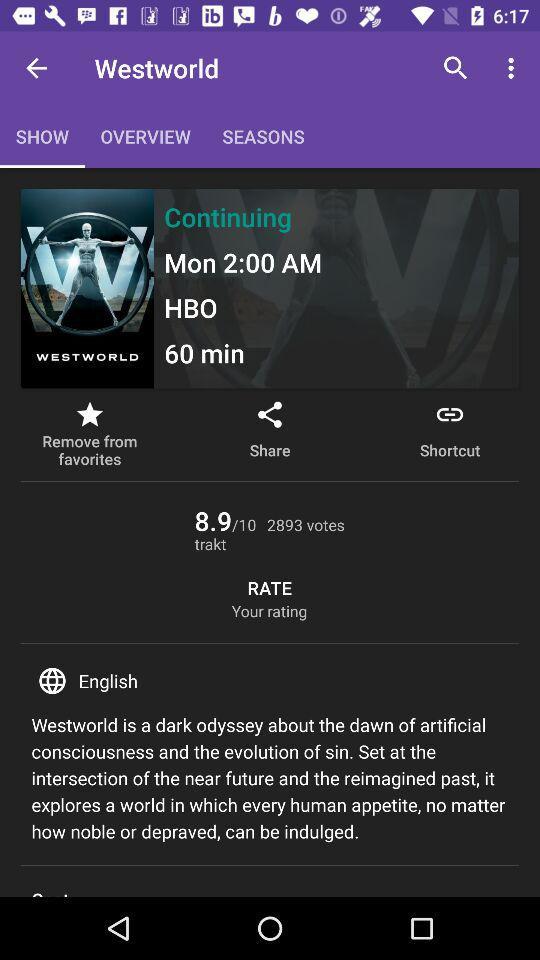What is the rating of the show?
Answer the question using a single word or phrase. 8.9/10 